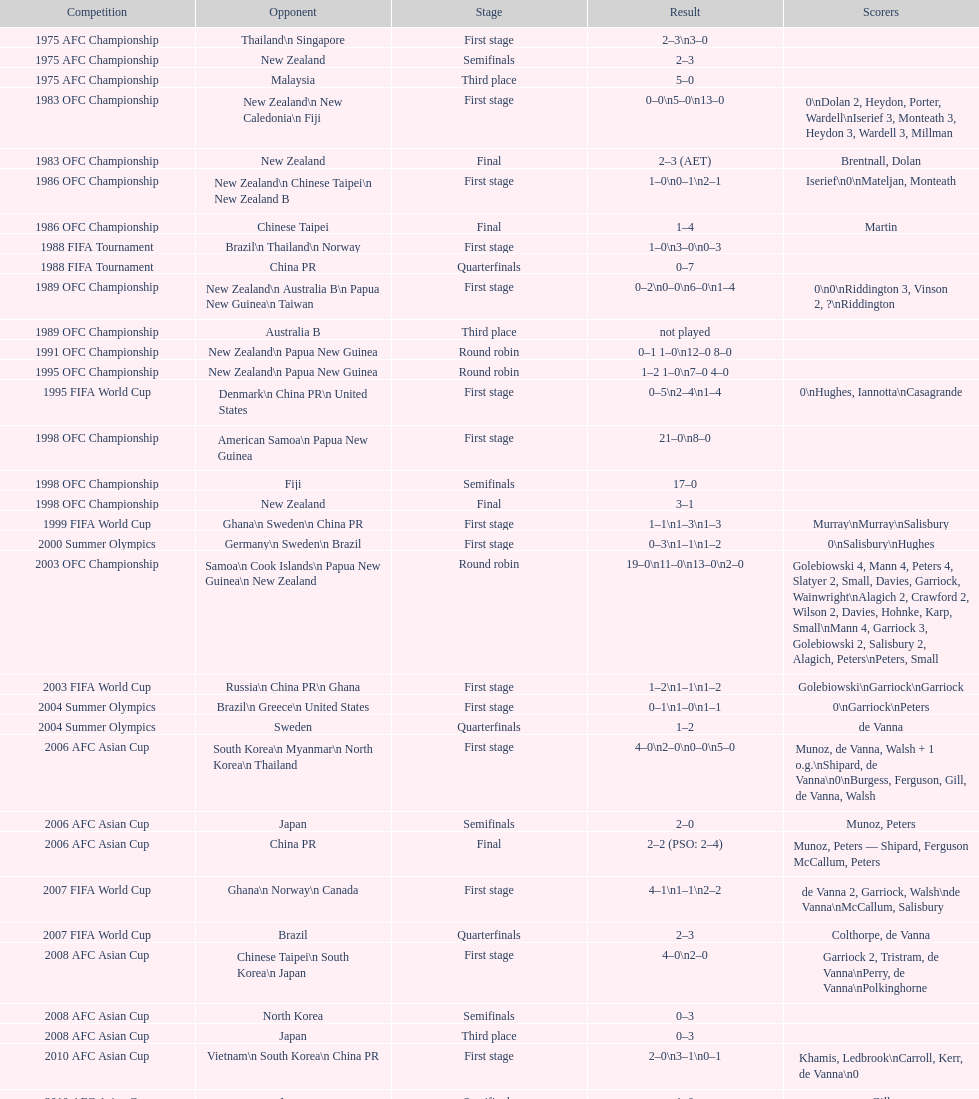What was the total goals made in the 1983 ofc championship? 18. 